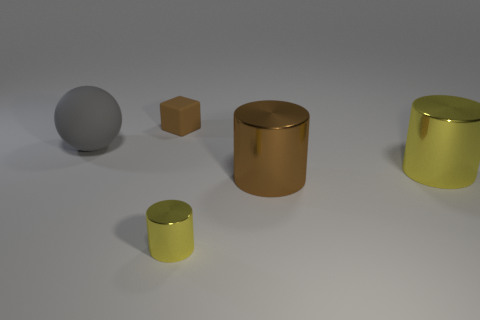The big yellow object has what shape?
Keep it short and to the point. Cylinder. Does the tiny object in front of the gray rubber sphere have the same color as the rubber sphere?
Make the answer very short. No. There is another yellow metal object that is the same shape as the large yellow shiny thing; what is its size?
Your answer should be very brief. Small. Is there any other thing that has the same material as the ball?
Provide a succinct answer. Yes. Is there a cube on the left side of the large thing that is on the left side of the matte thing that is behind the big gray object?
Offer a terse response. No. There is a small thing that is in front of the tiny block; what is its material?
Your answer should be very brief. Metal. What number of small objects are either gray matte things or brown matte cubes?
Provide a short and direct response. 1. Does the matte thing right of the gray ball have the same size as the brown metal cylinder?
Ensure brevity in your answer.  No. What number of other objects are the same color as the sphere?
Make the answer very short. 0. What material is the brown cylinder?
Provide a short and direct response. Metal. 